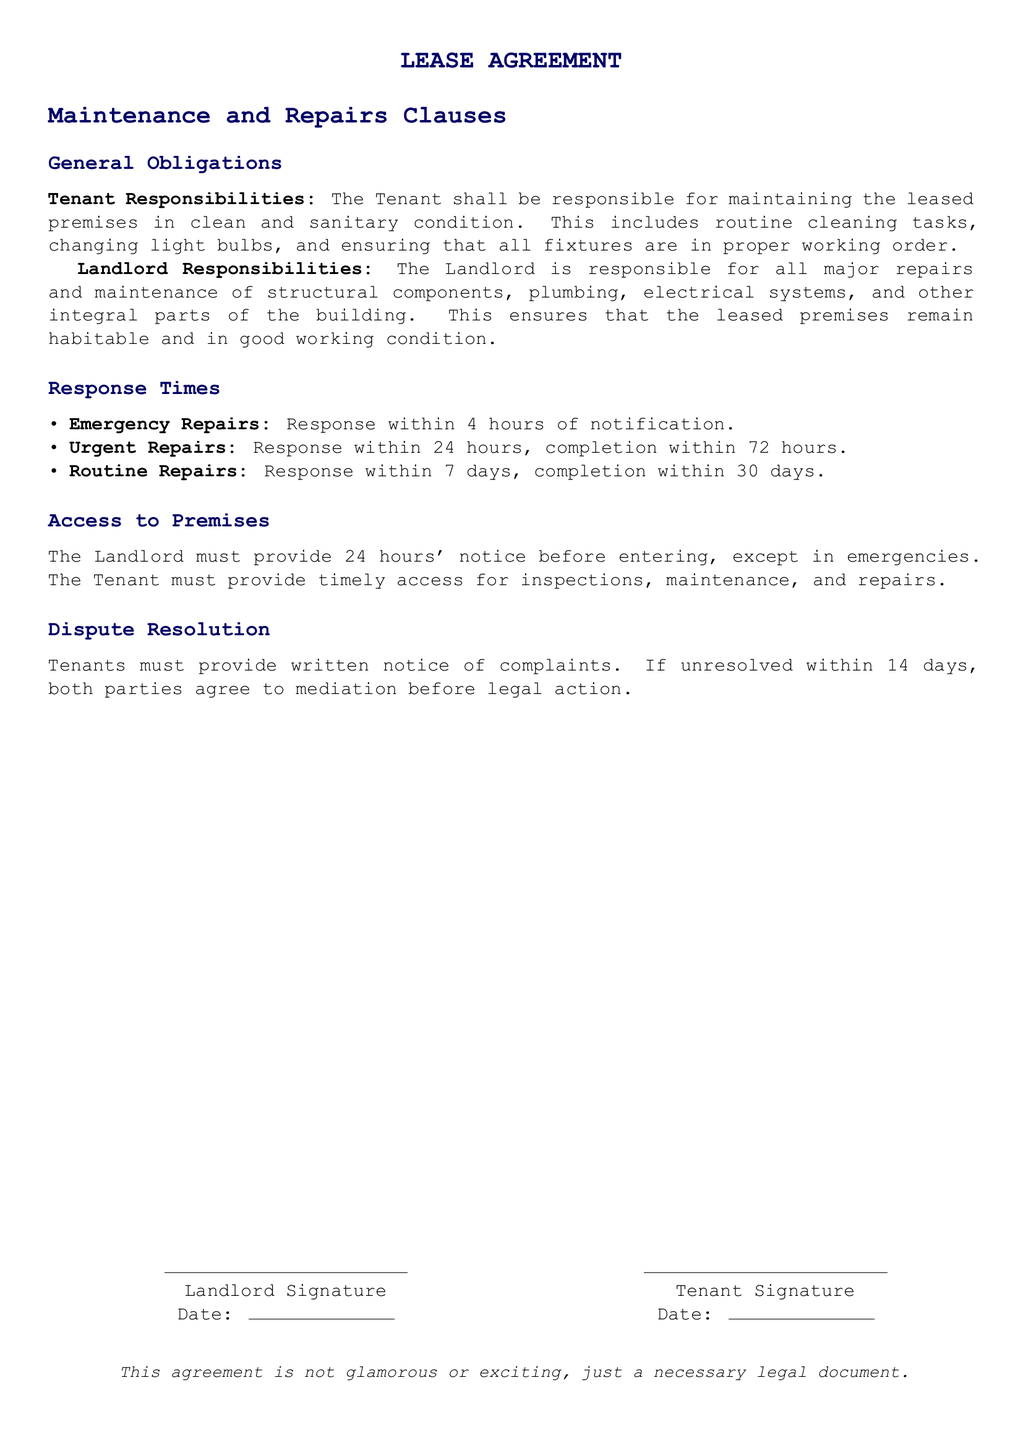What is the response time for emergency repairs? The document specifies that emergency repairs must be responded to within 4 hours of notification.
Answer: 4 hours What are the Tenant's responsibilities? The Tenant is responsible for maintaining the leased premises in clean and sanitary condition, which includes routine cleaning tasks, changing light bulbs, and ensuring all fixtures work properly.
Answer: Clean and sanitary condition What is the completion time for urgent repairs? According to the document, urgent repairs must be completed within 72 hours after a response within 24 hours.
Answer: 72 hours How much notice must the Landlord provide before entering the premises? The document states that the Landlord must provide 24 hours' notice before entering, except in emergencies.
Answer: 24 hours What is the process for unresolved complaints? The document outlines that if complaints are unresolved within 14 days, both parties agree to mediation before taking legal action.
Answer: Mediation What is the Tenant's obligation for routine repairs response time? The Tenant is expected to respond to routine repairs within 7 days.
Answer: 7 days What type of repairs requires a response within 24 hours? The document highlights that urgent repairs require a response within 24 hours.
Answer: Urgent repairs What must the Tenant provide for inspections and maintenance? The Tenant must provide timely access for inspections, maintenance, and repairs.
Answer: Timely access What is the Landlord's responsibility regarding the building's structural components? The Landlord is responsible for all major repairs and maintenance of structural components.
Answer: Major repairs 